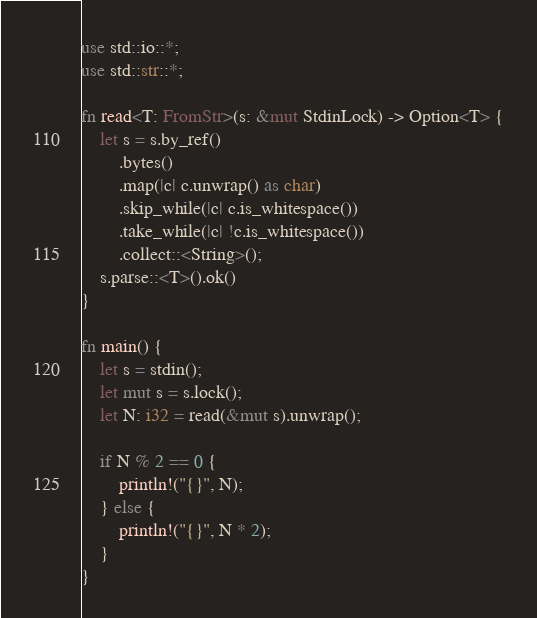<code> <loc_0><loc_0><loc_500><loc_500><_Rust_>use std::io::*;
use std::str::*;

fn read<T: FromStr>(s: &mut StdinLock) -> Option<T> {
    let s = s.by_ref()
        .bytes()
        .map(|c| c.unwrap() as char)
        .skip_while(|c| c.is_whitespace())
        .take_while(|c| !c.is_whitespace())
        .collect::<String>();
    s.parse::<T>().ok()
}

fn main() {
    let s = stdin();
    let mut s = s.lock();
    let N: i32 = read(&mut s).unwrap();

    if N % 2 == 0 {
        println!("{}", N);
    } else {
        println!("{}", N * 2);
    }
}
</code> 